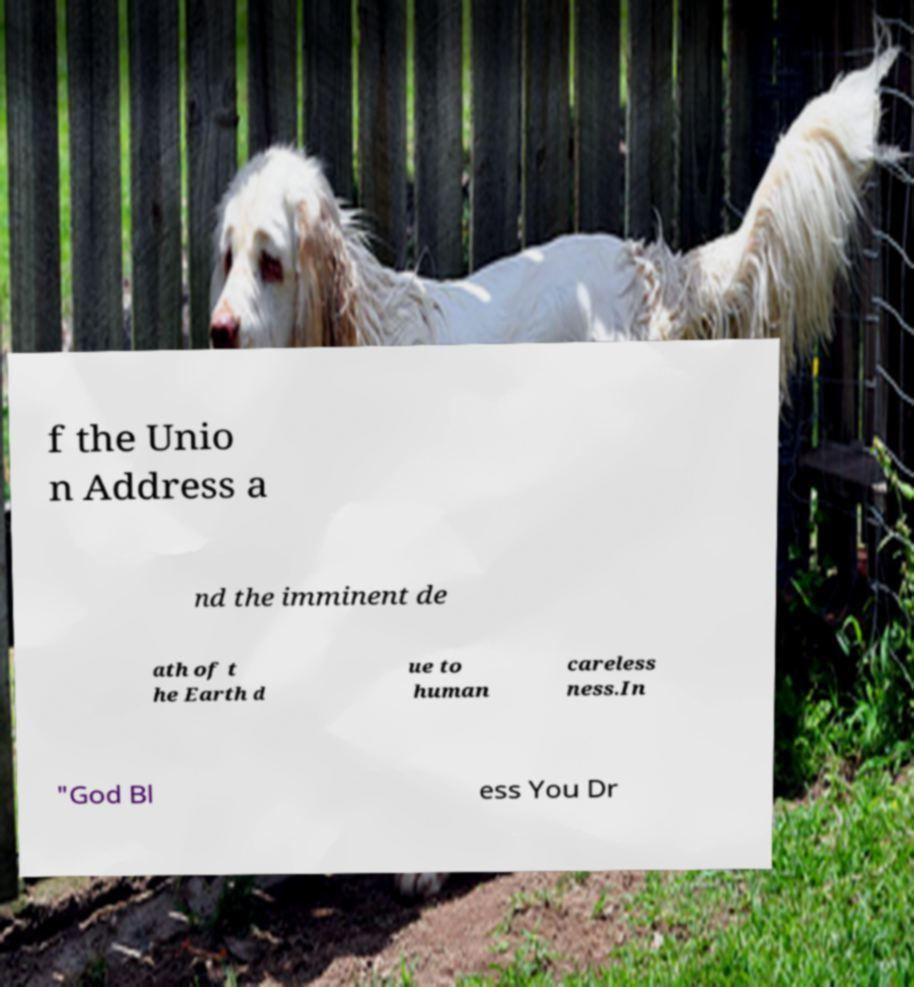What messages or text are displayed in this image? I need them in a readable, typed format. f the Unio n Address a nd the imminent de ath of t he Earth d ue to human careless ness.In "God Bl ess You Dr 